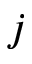<formula> <loc_0><loc_0><loc_500><loc_500>j</formula> 